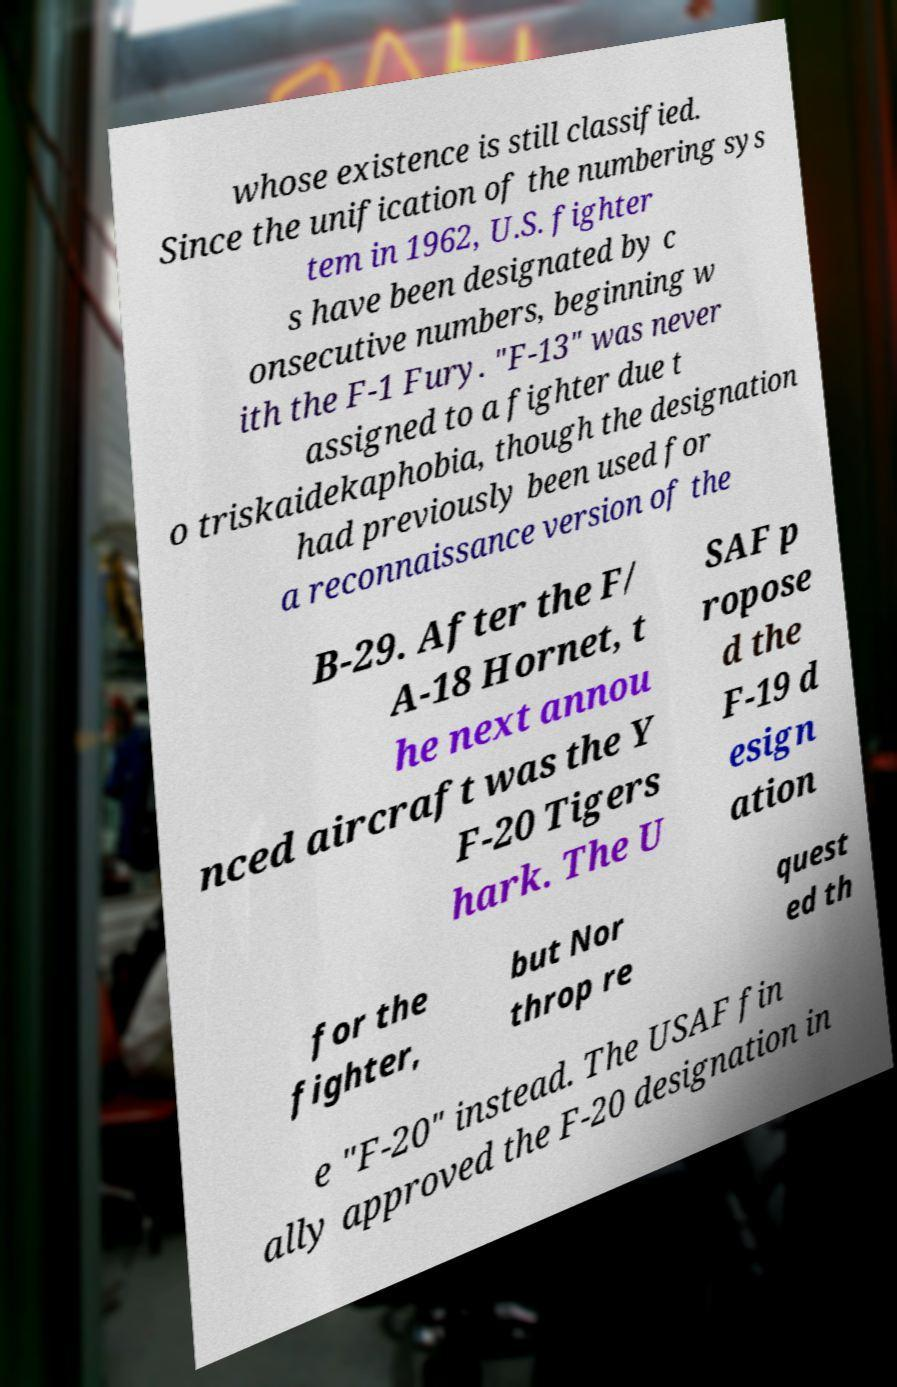Could you assist in decoding the text presented in this image and type it out clearly? whose existence is still classified. Since the unification of the numbering sys tem in 1962, U.S. fighter s have been designated by c onsecutive numbers, beginning w ith the F-1 Fury. "F-13" was never assigned to a fighter due t o triskaidekaphobia, though the designation had previously been used for a reconnaissance version of the B-29. After the F/ A-18 Hornet, t he next annou nced aircraft was the Y F-20 Tigers hark. The U SAF p ropose d the F-19 d esign ation for the fighter, but Nor throp re quest ed th e "F-20" instead. The USAF fin ally approved the F-20 designation in 